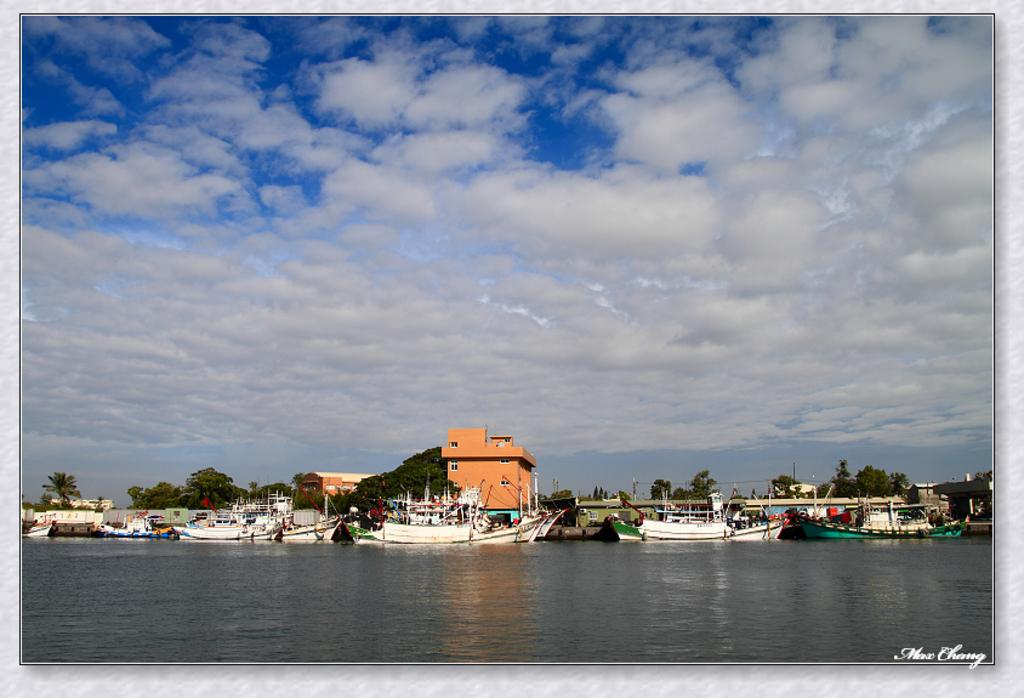What body of water is visible in the image? There is a lake in the image. What is on the lake? There are boats on the lake. What can be seen behind the lake? There are buildings and trees behind the lake. What is visible in the sky? The sky is visible in the image, and clouds are present. Where is the scarecrow located in the image? There is no scarecrow present in the image. How does the family interact with the boats in the image? There is no family present in the image, so their interaction with the boats cannot be determined. 